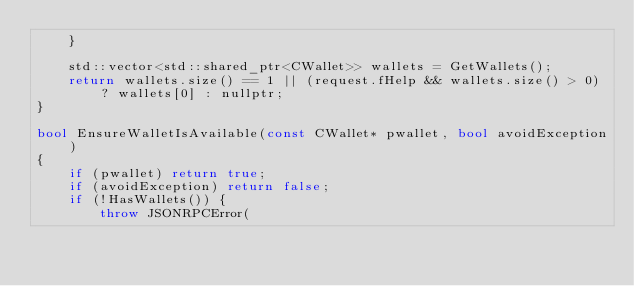<code> <loc_0><loc_0><loc_500><loc_500><_C++_>    }

    std::vector<std::shared_ptr<CWallet>> wallets = GetWallets();
    return wallets.size() == 1 || (request.fHelp && wallets.size() > 0) ? wallets[0] : nullptr;
}

bool EnsureWalletIsAvailable(const CWallet* pwallet, bool avoidException)
{
    if (pwallet) return true;
    if (avoidException) return false;
    if (!HasWallets()) {
        throw JSONRPCError(</code> 